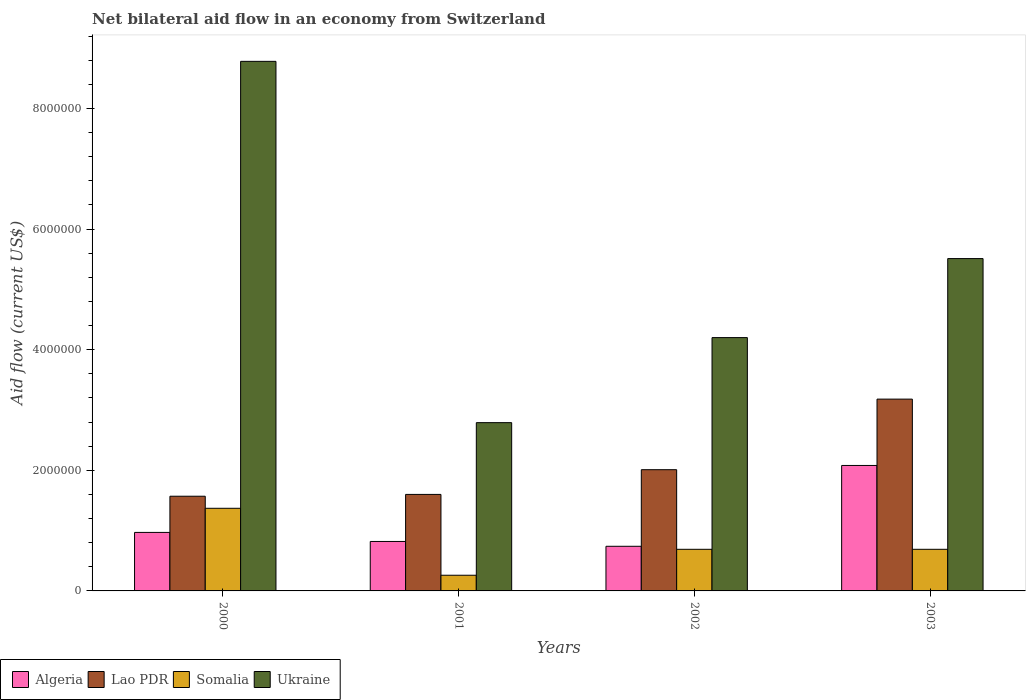Are the number of bars on each tick of the X-axis equal?
Give a very brief answer. Yes. How many bars are there on the 4th tick from the right?
Give a very brief answer. 4. What is the label of the 4th group of bars from the left?
Make the answer very short. 2003. In how many cases, is the number of bars for a given year not equal to the number of legend labels?
Offer a terse response. 0. What is the net bilateral aid flow in Somalia in 2003?
Make the answer very short. 6.90e+05. Across all years, what is the maximum net bilateral aid flow in Somalia?
Give a very brief answer. 1.37e+06. Across all years, what is the minimum net bilateral aid flow in Ukraine?
Give a very brief answer. 2.79e+06. What is the total net bilateral aid flow in Algeria in the graph?
Your answer should be compact. 4.61e+06. What is the difference between the net bilateral aid flow in Somalia in 2001 and that in 2003?
Provide a short and direct response. -4.30e+05. What is the average net bilateral aid flow in Lao PDR per year?
Keep it short and to the point. 2.09e+06. In the year 2003, what is the difference between the net bilateral aid flow in Lao PDR and net bilateral aid flow in Somalia?
Offer a very short reply. 2.49e+06. What is the ratio of the net bilateral aid flow in Algeria in 2001 to that in 2003?
Keep it short and to the point. 0.39. Is the difference between the net bilateral aid flow in Lao PDR in 2001 and 2003 greater than the difference between the net bilateral aid flow in Somalia in 2001 and 2003?
Make the answer very short. No. What is the difference between the highest and the second highest net bilateral aid flow in Ukraine?
Make the answer very short. 3.27e+06. What is the difference between the highest and the lowest net bilateral aid flow in Somalia?
Ensure brevity in your answer.  1.11e+06. In how many years, is the net bilateral aid flow in Algeria greater than the average net bilateral aid flow in Algeria taken over all years?
Make the answer very short. 1. Is it the case that in every year, the sum of the net bilateral aid flow in Ukraine and net bilateral aid flow in Lao PDR is greater than the sum of net bilateral aid flow in Algeria and net bilateral aid flow in Somalia?
Offer a very short reply. Yes. What does the 3rd bar from the left in 2002 represents?
Make the answer very short. Somalia. What does the 3rd bar from the right in 2002 represents?
Offer a very short reply. Lao PDR. Is it the case that in every year, the sum of the net bilateral aid flow in Lao PDR and net bilateral aid flow in Somalia is greater than the net bilateral aid flow in Algeria?
Your response must be concise. Yes. How many bars are there?
Your response must be concise. 16. Are all the bars in the graph horizontal?
Offer a very short reply. No. How many years are there in the graph?
Offer a terse response. 4. Are the values on the major ticks of Y-axis written in scientific E-notation?
Offer a terse response. No. Does the graph contain any zero values?
Make the answer very short. No. Does the graph contain grids?
Your response must be concise. No. Where does the legend appear in the graph?
Keep it short and to the point. Bottom left. How many legend labels are there?
Ensure brevity in your answer.  4. How are the legend labels stacked?
Your response must be concise. Horizontal. What is the title of the graph?
Ensure brevity in your answer.  Net bilateral aid flow in an economy from Switzerland. Does "Hong Kong" appear as one of the legend labels in the graph?
Make the answer very short. No. What is the label or title of the X-axis?
Your answer should be compact. Years. What is the Aid flow (current US$) in Algeria in 2000?
Provide a short and direct response. 9.70e+05. What is the Aid flow (current US$) of Lao PDR in 2000?
Give a very brief answer. 1.57e+06. What is the Aid flow (current US$) in Somalia in 2000?
Offer a terse response. 1.37e+06. What is the Aid flow (current US$) in Ukraine in 2000?
Provide a short and direct response. 8.78e+06. What is the Aid flow (current US$) in Algeria in 2001?
Make the answer very short. 8.20e+05. What is the Aid flow (current US$) in Lao PDR in 2001?
Offer a very short reply. 1.60e+06. What is the Aid flow (current US$) of Somalia in 2001?
Make the answer very short. 2.60e+05. What is the Aid flow (current US$) in Ukraine in 2001?
Offer a terse response. 2.79e+06. What is the Aid flow (current US$) in Algeria in 2002?
Keep it short and to the point. 7.40e+05. What is the Aid flow (current US$) of Lao PDR in 2002?
Keep it short and to the point. 2.01e+06. What is the Aid flow (current US$) of Somalia in 2002?
Ensure brevity in your answer.  6.90e+05. What is the Aid flow (current US$) in Ukraine in 2002?
Ensure brevity in your answer.  4.20e+06. What is the Aid flow (current US$) of Algeria in 2003?
Provide a short and direct response. 2.08e+06. What is the Aid flow (current US$) in Lao PDR in 2003?
Provide a succinct answer. 3.18e+06. What is the Aid flow (current US$) in Somalia in 2003?
Give a very brief answer. 6.90e+05. What is the Aid flow (current US$) in Ukraine in 2003?
Your answer should be very brief. 5.51e+06. Across all years, what is the maximum Aid flow (current US$) in Algeria?
Give a very brief answer. 2.08e+06. Across all years, what is the maximum Aid flow (current US$) in Lao PDR?
Your response must be concise. 3.18e+06. Across all years, what is the maximum Aid flow (current US$) of Somalia?
Make the answer very short. 1.37e+06. Across all years, what is the maximum Aid flow (current US$) of Ukraine?
Your answer should be very brief. 8.78e+06. Across all years, what is the minimum Aid flow (current US$) in Algeria?
Keep it short and to the point. 7.40e+05. Across all years, what is the minimum Aid flow (current US$) in Lao PDR?
Ensure brevity in your answer.  1.57e+06. Across all years, what is the minimum Aid flow (current US$) in Ukraine?
Offer a terse response. 2.79e+06. What is the total Aid flow (current US$) of Algeria in the graph?
Provide a succinct answer. 4.61e+06. What is the total Aid flow (current US$) of Lao PDR in the graph?
Provide a short and direct response. 8.36e+06. What is the total Aid flow (current US$) in Somalia in the graph?
Provide a short and direct response. 3.01e+06. What is the total Aid flow (current US$) of Ukraine in the graph?
Your response must be concise. 2.13e+07. What is the difference between the Aid flow (current US$) in Algeria in 2000 and that in 2001?
Your answer should be very brief. 1.50e+05. What is the difference between the Aid flow (current US$) in Somalia in 2000 and that in 2001?
Provide a short and direct response. 1.11e+06. What is the difference between the Aid flow (current US$) of Ukraine in 2000 and that in 2001?
Your answer should be compact. 5.99e+06. What is the difference between the Aid flow (current US$) of Lao PDR in 2000 and that in 2002?
Ensure brevity in your answer.  -4.40e+05. What is the difference between the Aid flow (current US$) in Somalia in 2000 and that in 2002?
Your response must be concise. 6.80e+05. What is the difference between the Aid flow (current US$) of Ukraine in 2000 and that in 2002?
Offer a very short reply. 4.58e+06. What is the difference between the Aid flow (current US$) of Algeria in 2000 and that in 2003?
Ensure brevity in your answer.  -1.11e+06. What is the difference between the Aid flow (current US$) in Lao PDR in 2000 and that in 2003?
Offer a terse response. -1.61e+06. What is the difference between the Aid flow (current US$) of Somalia in 2000 and that in 2003?
Offer a very short reply. 6.80e+05. What is the difference between the Aid flow (current US$) in Ukraine in 2000 and that in 2003?
Your response must be concise. 3.27e+06. What is the difference between the Aid flow (current US$) of Algeria in 2001 and that in 2002?
Your response must be concise. 8.00e+04. What is the difference between the Aid flow (current US$) of Lao PDR in 2001 and that in 2002?
Keep it short and to the point. -4.10e+05. What is the difference between the Aid flow (current US$) in Somalia in 2001 and that in 2002?
Provide a succinct answer. -4.30e+05. What is the difference between the Aid flow (current US$) of Ukraine in 2001 and that in 2002?
Make the answer very short. -1.41e+06. What is the difference between the Aid flow (current US$) of Algeria in 2001 and that in 2003?
Ensure brevity in your answer.  -1.26e+06. What is the difference between the Aid flow (current US$) in Lao PDR in 2001 and that in 2003?
Offer a very short reply. -1.58e+06. What is the difference between the Aid flow (current US$) in Somalia in 2001 and that in 2003?
Provide a short and direct response. -4.30e+05. What is the difference between the Aid flow (current US$) in Ukraine in 2001 and that in 2003?
Your response must be concise. -2.72e+06. What is the difference between the Aid flow (current US$) in Algeria in 2002 and that in 2003?
Your answer should be compact. -1.34e+06. What is the difference between the Aid flow (current US$) of Lao PDR in 2002 and that in 2003?
Make the answer very short. -1.17e+06. What is the difference between the Aid flow (current US$) in Somalia in 2002 and that in 2003?
Keep it short and to the point. 0. What is the difference between the Aid flow (current US$) of Ukraine in 2002 and that in 2003?
Your answer should be compact. -1.31e+06. What is the difference between the Aid flow (current US$) of Algeria in 2000 and the Aid flow (current US$) of Lao PDR in 2001?
Offer a terse response. -6.30e+05. What is the difference between the Aid flow (current US$) in Algeria in 2000 and the Aid flow (current US$) in Somalia in 2001?
Your response must be concise. 7.10e+05. What is the difference between the Aid flow (current US$) of Algeria in 2000 and the Aid flow (current US$) of Ukraine in 2001?
Your answer should be compact. -1.82e+06. What is the difference between the Aid flow (current US$) of Lao PDR in 2000 and the Aid flow (current US$) of Somalia in 2001?
Keep it short and to the point. 1.31e+06. What is the difference between the Aid flow (current US$) of Lao PDR in 2000 and the Aid flow (current US$) of Ukraine in 2001?
Offer a very short reply. -1.22e+06. What is the difference between the Aid flow (current US$) of Somalia in 2000 and the Aid flow (current US$) of Ukraine in 2001?
Your answer should be very brief. -1.42e+06. What is the difference between the Aid flow (current US$) of Algeria in 2000 and the Aid flow (current US$) of Lao PDR in 2002?
Give a very brief answer. -1.04e+06. What is the difference between the Aid flow (current US$) in Algeria in 2000 and the Aid flow (current US$) in Ukraine in 2002?
Your answer should be very brief. -3.23e+06. What is the difference between the Aid flow (current US$) of Lao PDR in 2000 and the Aid flow (current US$) of Somalia in 2002?
Keep it short and to the point. 8.80e+05. What is the difference between the Aid flow (current US$) in Lao PDR in 2000 and the Aid flow (current US$) in Ukraine in 2002?
Ensure brevity in your answer.  -2.63e+06. What is the difference between the Aid flow (current US$) in Somalia in 2000 and the Aid flow (current US$) in Ukraine in 2002?
Provide a succinct answer. -2.83e+06. What is the difference between the Aid flow (current US$) of Algeria in 2000 and the Aid flow (current US$) of Lao PDR in 2003?
Offer a very short reply. -2.21e+06. What is the difference between the Aid flow (current US$) of Algeria in 2000 and the Aid flow (current US$) of Somalia in 2003?
Provide a succinct answer. 2.80e+05. What is the difference between the Aid flow (current US$) of Algeria in 2000 and the Aid flow (current US$) of Ukraine in 2003?
Your response must be concise. -4.54e+06. What is the difference between the Aid flow (current US$) in Lao PDR in 2000 and the Aid flow (current US$) in Somalia in 2003?
Make the answer very short. 8.80e+05. What is the difference between the Aid flow (current US$) in Lao PDR in 2000 and the Aid flow (current US$) in Ukraine in 2003?
Offer a very short reply. -3.94e+06. What is the difference between the Aid flow (current US$) in Somalia in 2000 and the Aid flow (current US$) in Ukraine in 2003?
Ensure brevity in your answer.  -4.14e+06. What is the difference between the Aid flow (current US$) of Algeria in 2001 and the Aid flow (current US$) of Lao PDR in 2002?
Your answer should be compact. -1.19e+06. What is the difference between the Aid flow (current US$) of Algeria in 2001 and the Aid flow (current US$) of Ukraine in 2002?
Your response must be concise. -3.38e+06. What is the difference between the Aid flow (current US$) in Lao PDR in 2001 and the Aid flow (current US$) in Somalia in 2002?
Give a very brief answer. 9.10e+05. What is the difference between the Aid flow (current US$) of Lao PDR in 2001 and the Aid flow (current US$) of Ukraine in 2002?
Your answer should be very brief. -2.60e+06. What is the difference between the Aid flow (current US$) in Somalia in 2001 and the Aid flow (current US$) in Ukraine in 2002?
Your response must be concise. -3.94e+06. What is the difference between the Aid flow (current US$) of Algeria in 2001 and the Aid flow (current US$) of Lao PDR in 2003?
Offer a very short reply. -2.36e+06. What is the difference between the Aid flow (current US$) of Algeria in 2001 and the Aid flow (current US$) of Somalia in 2003?
Give a very brief answer. 1.30e+05. What is the difference between the Aid flow (current US$) of Algeria in 2001 and the Aid flow (current US$) of Ukraine in 2003?
Ensure brevity in your answer.  -4.69e+06. What is the difference between the Aid flow (current US$) in Lao PDR in 2001 and the Aid flow (current US$) in Somalia in 2003?
Provide a succinct answer. 9.10e+05. What is the difference between the Aid flow (current US$) in Lao PDR in 2001 and the Aid flow (current US$) in Ukraine in 2003?
Offer a terse response. -3.91e+06. What is the difference between the Aid flow (current US$) of Somalia in 2001 and the Aid flow (current US$) of Ukraine in 2003?
Your answer should be compact. -5.25e+06. What is the difference between the Aid flow (current US$) in Algeria in 2002 and the Aid flow (current US$) in Lao PDR in 2003?
Offer a very short reply. -2.44e+06. What is the difference between the Aid flow (current US$) in Algeria in 2002 and the Aid flow (current US$) in Ukraine in 2003?
Your answer should be very brief. -4.77e+06. What is the difference between the Aid flow (current US$) of Lao PDR in 2002 and the Aid flow (current US$) of Somalia in 2003?
Offer a terse response. 1.32e+06. What is the difference between the Aid flow (current US$) in Lao PDR in 2002 and the Aid flow (current US$) in Ukraine in 2003?
Your answer should be very brief. -3.50e+06. What is the difference between the Aid flow (current US$) of Somalia in 2002 and the Aid flow (current US$) of Ukraine in 2003?
Your answer should be compact. -4.82e+06. What is the average Aid flow (current US$) in Algeria per year?
Your answer should be very brief. 1.15e+06. What is the average Aid flow (current US$) of Lao PDR per year?
Ensure brevity in your answer.  2.09e+06. What is the average Aid flow (current US$) in Somalia per year?
Your response must be concise. 7.52e+05. What is the average Aid flow (current US$) of Ukraine per year?
Your answer should be very brief. 5.32e+06. In the year 2000, what is the difference between the Aid flow (current US$) in Algeria and Aid flow (current US$) in Lao PDR?
Provide a succinct answer. -6.00e+05. In the year 2000, what is the difference between the Aid flow (current US$) in Algeria and Aid flow (current US$) in Somalia?
Make the answer very short. -4.00e+05. In the year 2000, what is the difference between the Aid flow (current US$) in Algeria and Aid flow (current US$) in Ukraine?
Offer a terse response. -7.81e+06. In the year 2000, what is the difference between the Aid flow (current US$) in Lao PDR and Aid flow (current US$) in Ukraine?
Keep it short and to the point. -7.21e+06. In the year 2000, what is the difference between the Aid flow (current US$) in Somalia and Aid flow (current US$) in Ukraine?
Provide a succinct answer. -7.41e+06. In the year 2001, what is the difference between the Aid flow (current US$) in Algeria and Aid flow (current US$) in Lao PDR?
Offer a terse response. -7.80e+05. In the year 2001, what is the difference between the Aid flow (current US$) of Algeria and Aid flow (current US$) of Somalia?
Provide a short and direct response. 5.60e+05. In the year 2001, what is the difference between the Aid flow (current US$) in Algeria and Aid flow (current US$) in Ukraine?
Your answer should be very brief. -1.97e+06. In the year 2001, what is the difference between the Aid flow (current US$) in Lao PDR and Aid flow (current US$) in Somalia?
Ensure brevity in your answer.  1.34e+06. In the year 2001, what is the difference between the Aid flow (current US$) of Lao PDR and Aid flow (current US$) of Ukraine?
Make the answer very short. -1.19e+06. In the year 2001, what is the difference between the Aid flow (current US$) of Somalia and Aid flow (current US$) of Ukraine?
Offer a terse response. -2.53e+06. In the year 2002, what is the difference between the Aid flow (current US$) in Algeria and Aid flow (current US$) in Lao PDR?
Your answer should be compact. -1.27e+06. In the year 2002, what is the difference between the Aid flow (current US$) in Algeria and Aid flow (current US$) in Ukraine?
Provide a short and direct response. -3.46e+06. In the year 2002, what is the difference between the Aid flow (current US$) of Lao PDR and Aid flow (current US$) of Somalia?
Offer a very short reply. 1.32e+06. In the year 2002, what is the difference between the Aid flow (current US$) in Lao PDR and Aid flow (current US$) in Ukraine?
Provide a succinct answer. -2.19e+06. In the year 2002, what is the difference between the Aid flow (current US$) of Somalia and Aid flow (current US$) of Ukraine?
Offer a terse response. -3.51e+06. In the year 2003, what is the difference between the Aid flow (current US$) in Algeria and Aid flow (current US$) in Lao PDR?
Ensure brevity in your answer.  -1.10e+06. In the year 2003, what is the difference between the Aid flow (current US$) of Algeria and Aid flow (current US$) of Somalia?
Make the answer very short. 1.39e+06. In the year 2003, what is the difference between the Aid flow (current US$) of Algeria and Aid flow (current US$) of Ukraine?
Provide a succinct answer. -3.43e+06. In the year 2003, what is the difference between the Aid flow (current US$) of Lao PDR and Aid flow (current US$) of Somalia?
Keep it short and to the point. 2.49e+06. In the year 2003, what is the difference between the Aid flow (current US$) of Lao PDR and Aid flow (current US$) of Ukraine?
Offer a terse response. -2.33e+06. In the year 2003, what is the difference between the Aid flow (current US$) in Somalia and Aid flow (current US$) in Ukraine?
Keep it short and to the point. -4.82e+06. What is the ratio of the Aid flow (current US$) of Algeria in 2000 to that in 2001?
Offer a very short reply. 1.18. What is the ratio of the Aid flow (current US$) in Lao PDR in 2000 to that in 2001?
Offer a terse response. 0.98. What is the ratio of the Aid flow (current US$) in Somalia in 2000 to that in 2001?
Give a very brief answer. 5.27. What is the ratio of the Aid flow (current US$) in Ukraine in 2000 to that in 2001?
Offer a very short reply. 3.15. What is the ratio of the Aid flow (current US$) in Algeria in 2000 to that in 2002?
Offer a terse response. 1.31. What is the ratio of the Aid flow (current US$) in Lao PDR in 2000 to that in 2002?
Keep it short and to the point. 0.78. What is the ratio of the Aid flow (current US$) of Somalia in 2000 to that in 2002?
Give a very brief answer. 1.99. What is the ratio of the Aid flow (current US$) of Ukraine in 2000 to that in 2002?
Make the answer very short. 2.09. What is the ratio of the Aid flow (current US$) in Algeria in 2000 to that in 2003?
Your answer should be very brief. 0.47. What is the ratio of the Aid flow (current US$) of Lao PDR in 2000 to that in 2003?
Provide a succinct answer. 0.49. What is the ratio of the Aid flow (current US$) in Somalia in 2000 to that in 2003?
Your answer should be very brief. 1.99. What is the ratio of the Aid flow (current US$) of Ukraine in 2000 to that in 2003?
Offer a very short reply. 1.59. What is the ratio of the Aid flow (current US$) in Algeria in 2001 to that in 2002?
Your response must be concise. 1.11. What is the ratio of the Aid flow (current US$) of Lao PDR in 2001 to that in 2002?
Your response must be concise. 0.8. What is the ratio of the Aid flow (current US$) of Somalia in 2001 to that in 2002?
Your answer should be compact. 0.38. What is the ratio of the Aid flow (current US$) of Ukraine in 2001 to that in 2002?
Offer a terse response. 0.66. What is the ratio of the Aid flow (current US$) in Algeria in 2001 to that in 2003?
Ensure brevity in your answer.  0.39. What is the ratio of the Aid flow (current US$) of Lao PDR in 2001 to that in 2003?
Your answer should be compact. 0.5. What is the ratio of the Aid flow (current US$) of Somalia in 2001 to that in 2003?
Offer a terse response. 0.38. What is the ratio of the Aid flow (current US$) of Ukraine in 2001 to that in 2003?
Give a very brief answer. 0.51. What is the ratio of the Aid flow (current US$) of Algeria in 2002 to that in 2003?
Ensure brevity in your answer.  0.36. What is the ratio of the Aid flow (current US$) in Lao PDR in 2002 to that in 2003?
Offer a very short reply. 0.63. What is the ratio of the Aid flow (current US$) in Ukraine in 2002 to that in 2003?
Keep it short and to the point. 0.76. What is the difference between the highest and the second highest Aid flow (current US$) in Algeria?
Your answer should be very brief. 1.11e+06. What is the difference between the highest and the second highest Aid flow (current US$) in Lao PDR?
Your response must be concise. 1.17e+06. What is the difference between the highest and the second highest Aid flow (current US$) of Somalia?
Provide a succinct answer. 6.80e+05. What is the difference between the highest and the second highest Aid flow (current US$) in Ukraine?
Give a very brief answer. 3.27e+06. What is the difference between the highest and the lowest Aid flow (current US$) in Algeria?
Your response must be concise. 1.34e+06. What is the difference between the highest and the lowest Aid flow (current US$) in Lao PDR?
Provide a short and direct response. 1.61e+06. What is the difference between the highest and the lowest Aid flow (current US$) in Somalia?
Keep it short and to the point. 1.11e+06. What is the difference between the highest and the lowest Aid flow (current US$) in Ukraine?
Make the answer very short. 5.99e+06. 